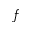<formula> <loc_0><loc_0><loc_500><loc_500>f</formula> 